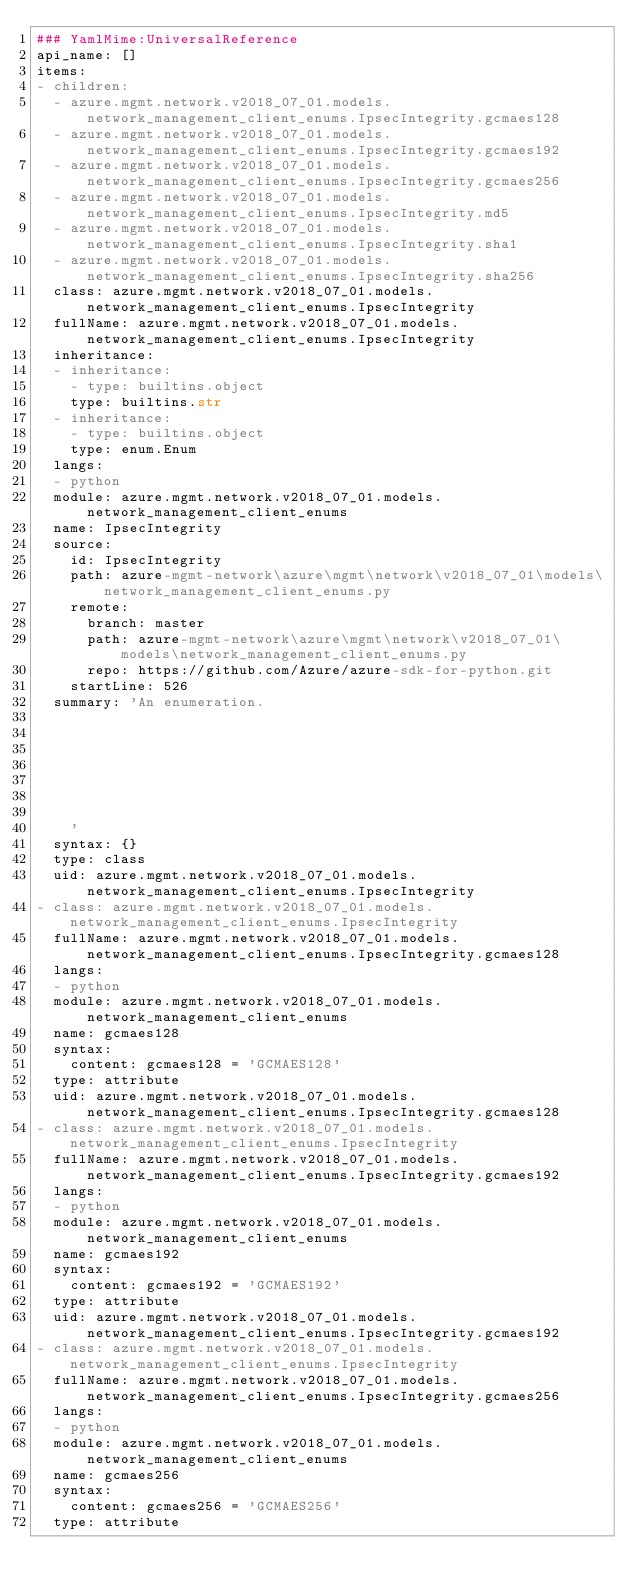Convert code to text. <code><loc_0><loc_0><loc_500><loc_500><_YAML_>### YamlMime:UniversalReference
api_name: []
items:
- children:
  - azure.mgmt.network.v2018_07_01.models.network_management_client_enums.IpsecIntegrity.gcmaes128
  - azure.mgmt.network.v2018_07_01.models.network_management_client_enums.IpsecIntegrity.gcmaes192
  - azure.mgmt.network.v2018_07_01.models.network_management_client_enums.IpsecIntegrity.gcmaes256
  - azure.mgmt.network.v2018_07_01.models.network_management_client_enums.IpsecIntegrity.md5
  - azure.mgmt.network.v2018_07_01.models.network_management_client_enums.IpsecIntegrity.sha1
  - azure.mgmt.network.v2018_07_01.models.network_management_client_enums.IpsecIntegrity.sha256
  class: azure.mgmt.network.v2018_07_01.models.network_management_client_enums.IpsecIntegrity
  fullName: azure.mgmt.network.v2018_07_01.models.network_management_client_enums.IpsecIntegrity
  inheritance:
  - inheritance:
    - type: builtins.object
    type: builtins.str
  - inheritance:
    - type: builtins.object
    type: enum.Enum
  langs:
  - python
  module: azure.mgmt.network.v2018_07_01.models.network_management_client_enums
  name: IpsecIntegrity
  source:
    id: IpsecIntegrity
    path: azure-mgmt-network\azure\mgmt\network\v2018_07_01\models\network_management_client_enums.py
    remote:
      branch: master
      path: azure-mgmt-network\azure\mgmt\network\v2018_07_01\models\network_management_client_enums.py
      repo: https://github.com/Azure/azure-sdk-for-python.git
    startLine: 526
  summary: 'An enumeration.







    '
  syntax: {}
  type: class
  uid: azure.mgmt.network.v2018_07_01.models.network_management_client_enums.IpsecIntegrity
- class: azure.mgmt.network.v2018_07_01.models.network_management_client_enums.IpsecIntegrity
  fullName: azure.mgmt.network.v2018_07_01.models.network_management_client_enums.IpsecIntegrity.gcmaes128
  langs:
  - python
  module: azure.mgmt.network.v2018_07_01.models.network_management_client_enums
  name: gcmaes128
  syntax:
    content: gcmaes128 = 'GCMAES128'
  type: attribute
  uid: azure.mgmt.network.v2018_07_01.models.network_management_client_enums.IpsecIntegrity.gcmaes128
- class: azure.mgmt.network.v2018_07_01.models.network_management_client_enums.IpsecIntegrity
  fullName: azure.mgmt.network.v2018_07_01.models.network_management_client_enums.IpsecIntegrity.gcmaes192
  langs:
  - python
  module: azure.mgmt.network.v2018_07_01.models.network_management_client_enums
  name: gcmaes192
  syntax:
    content: gcmaes192 = 'GCMAES192'
  type: attribute
  uid: azure.mgmt.network.v2018_07_01.models.network_management_client_enums.IpsecIntegrity.gcmaes192
- class: azure.mgmt.network.v2018_07_01.models.network_management_client_enums.IpsecIntegrity
  fullName: azure.mgmt.network.v2018_07_01.models.network_management_client_enums.IpsecIntegrity.gcmaes256
  langs:
  - python
  module: azure.mgmt.network.v2018_07_01.models.network_management_client_enums
  name: gcmaes256
  syntax:
    content: gcmaes256 = 'GCMAES256'
  type: attribute</code> 